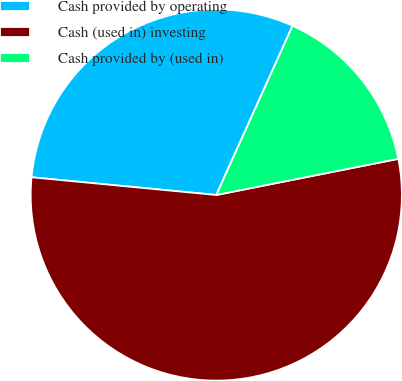Convert chart to OTSL. <chart><loc_0><loc_0><loc_500><loc_500><pie_chart><fcel>Cash provided by operating<fcel>Cash (used in) investing<fcel>Cash provided by (used in)<nl><fcel>30.22%<fcel>54.65%<fcel>15.14%<nl></chart> 